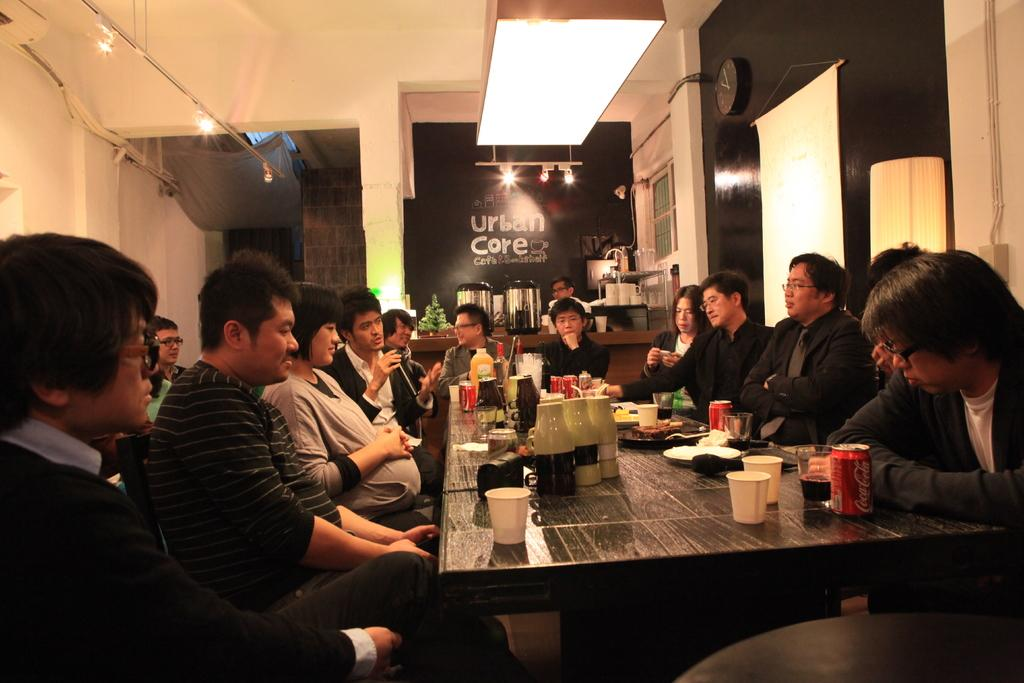<image>
Create a compact narrative representing the image presented. the word core that is on a black board 